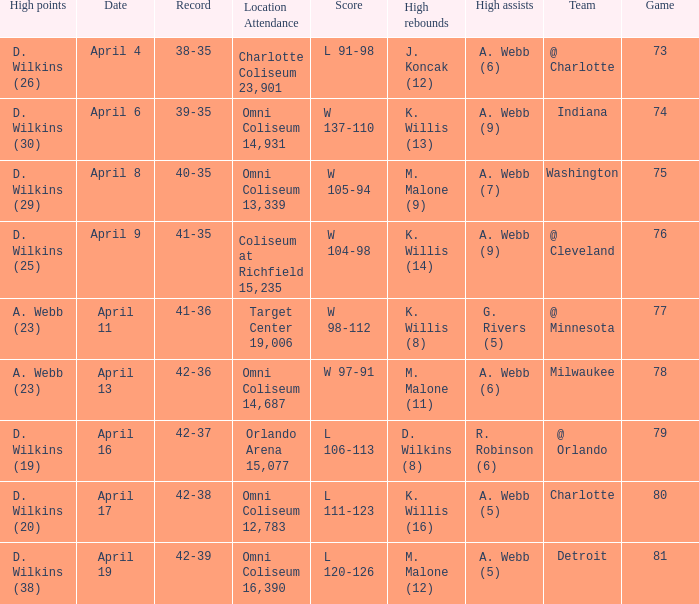Who had the high assists when the opponent was Indiana? A. Webb (9). 